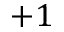Convert formula to latex. <formula><loc_0><loc_0><loc_500><loc_500>+ 1</formula> 